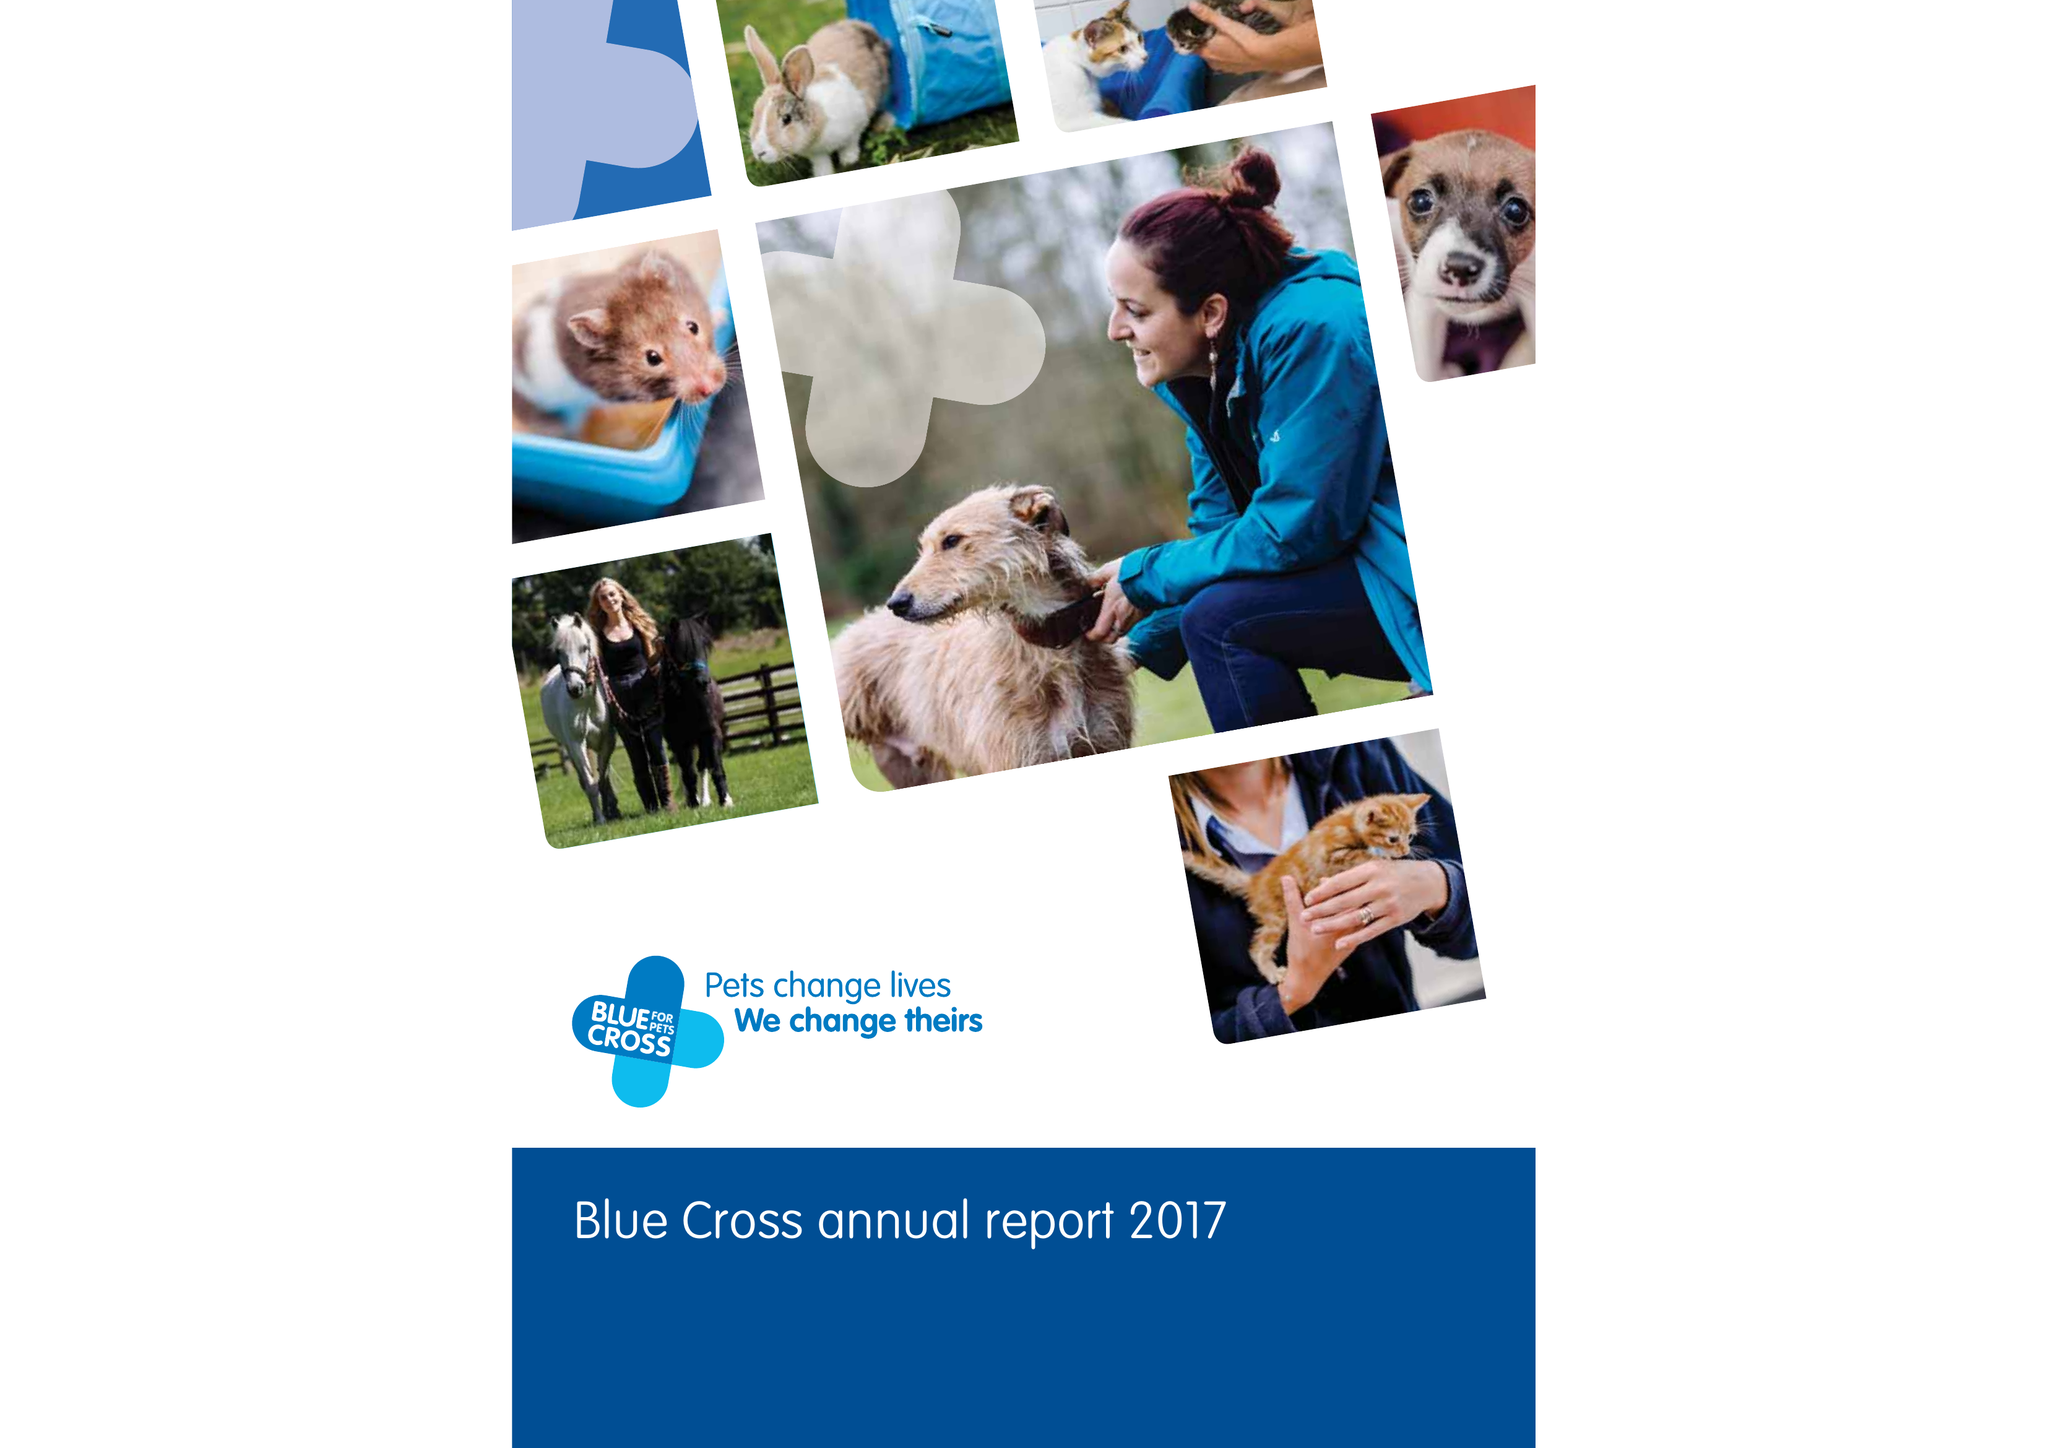What is the value for the income_annually_in_british_pounds?
Answer the question using a single word or phrase. 38964000.00 